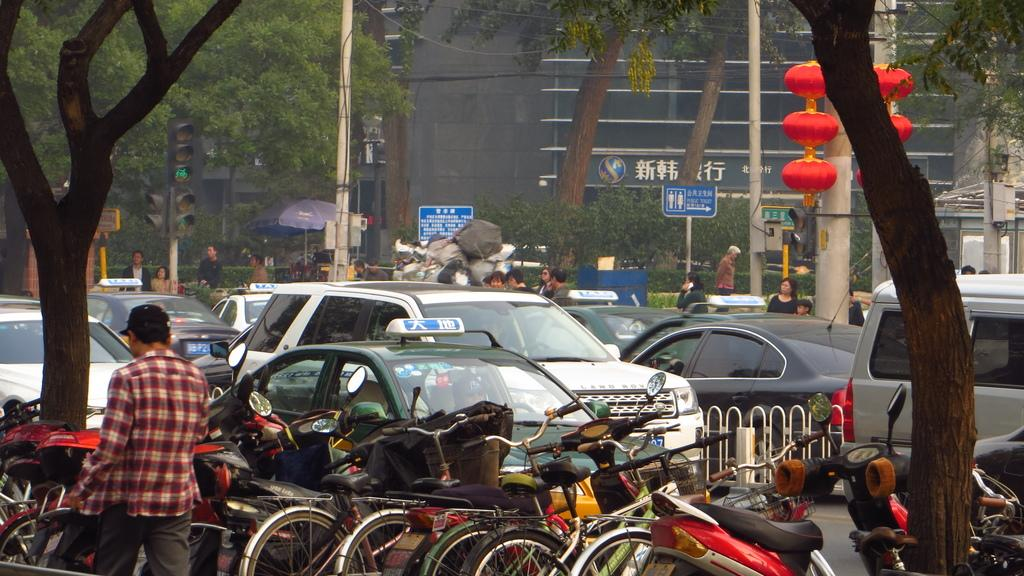What is the man in the image doing? The man is walking in the image. What else can be seen in the image besides the man? There are vehicles, a fence, trees, and people visible in the background. What structures are present in the background? Traffic signals, boards on poles, trees, and a building are present in the background. What type of soap is being used to clean the bike in the image? There is no bike or soap present in the image. What is the man's afterthought as he walks in the image? The provided facts do not mention any afterthoughts or thoughts of the man; we can only describe his actions in the image. 